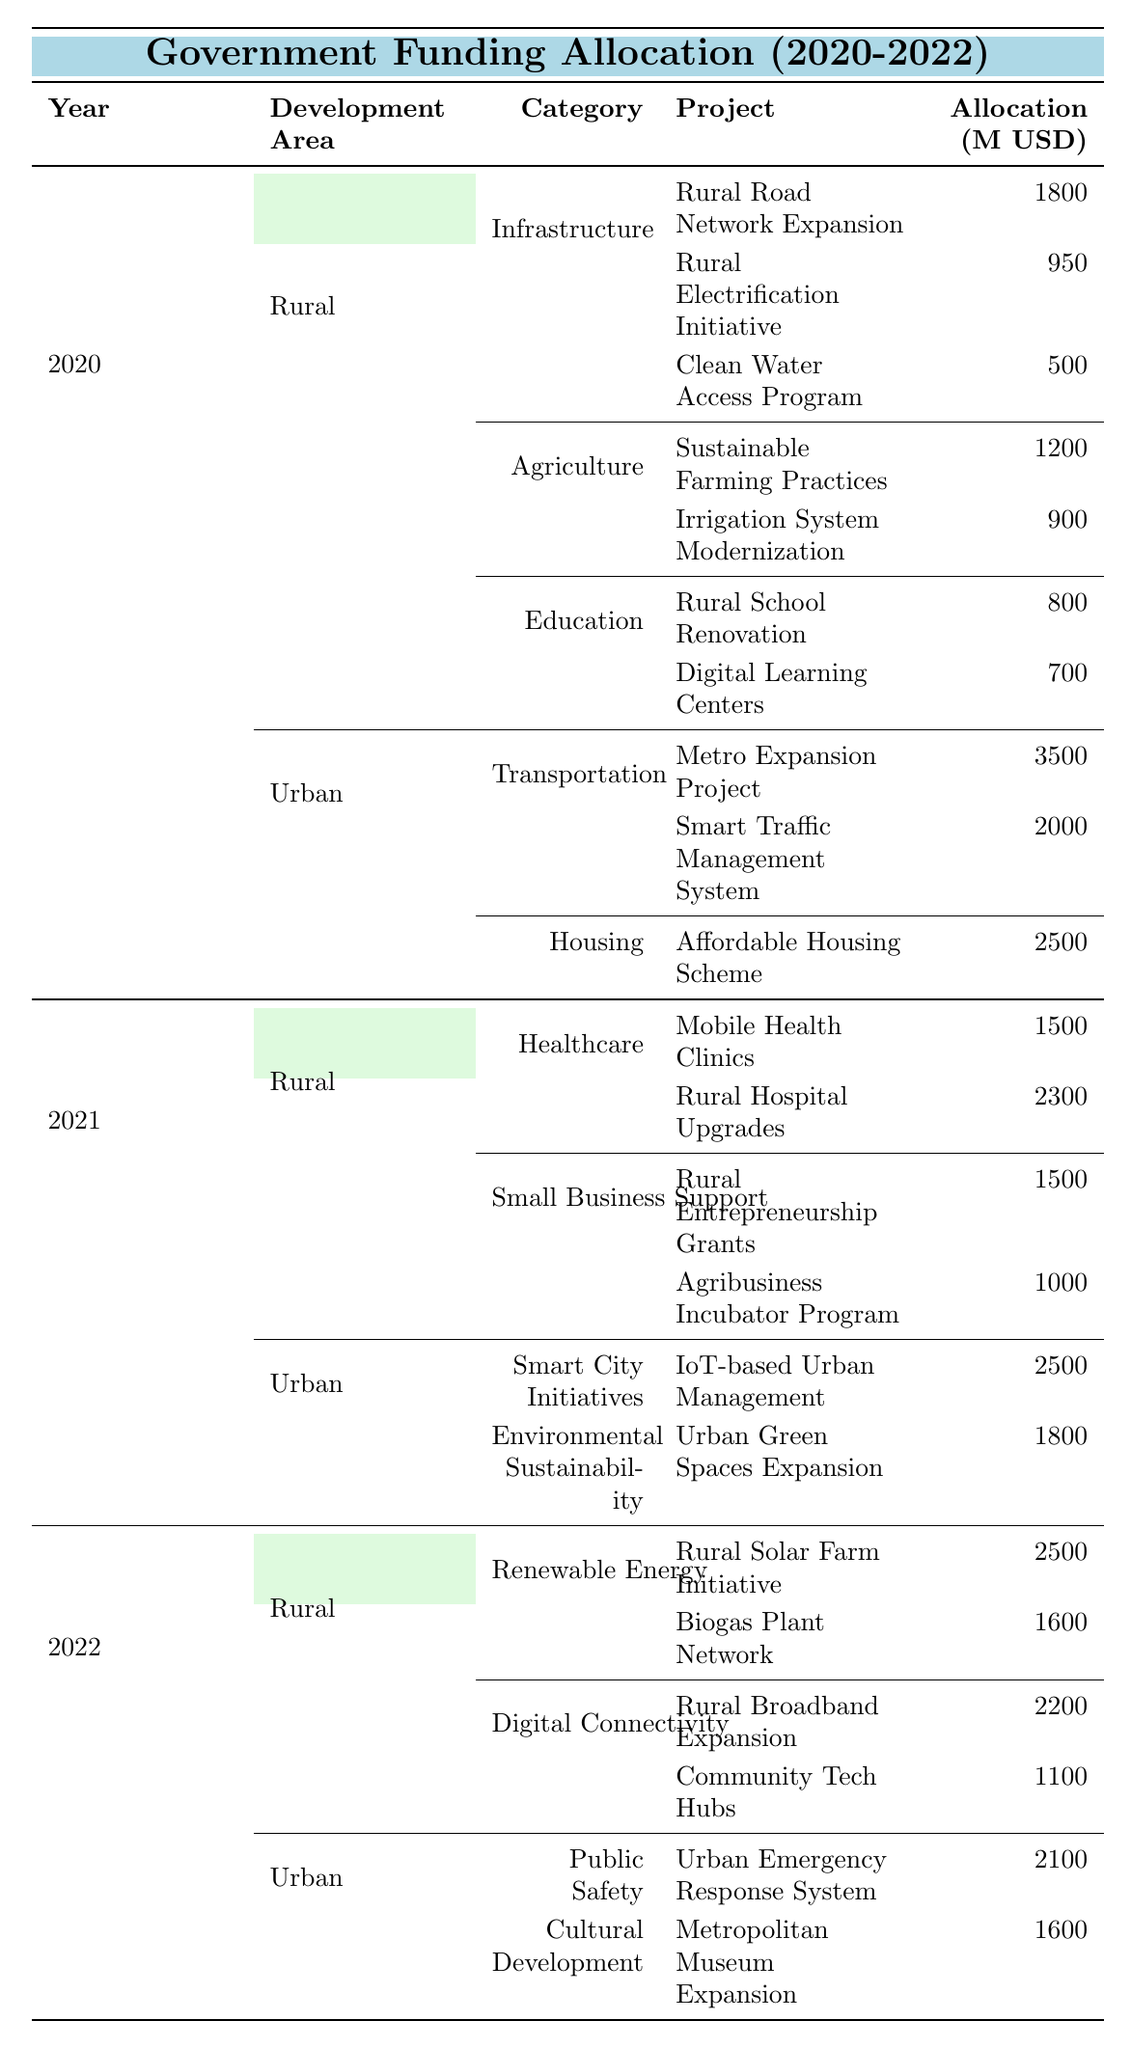What was the total allocation for rural development in 2020? In 2020, the rural development allocation consists of Infrastructure (3250 million USD), Agriculture (2100 million USD), and Education (1500 million USD). Adding these amounts gives: 3250 + 2100 + 1500 = 6850 million USD.
Answer: 6850 million USD Which urban project received the highest funding in 2021? In 2021, the highest funded urban project is the "IoT-based Urban Management" with an allocation of 2500 million USD under the Smart City Initiatives category.
Answer: 2500 million USD Did any rural projects receive more than 2000 million USD in allocations in 2022? In 2022, "Rural Solar Farm Initiative" received 2500 million USD and "Rural Hospital Upgrades" in 2021 received 2300 million USD. Both exceed 2000 million USD.
Answer: Yes What was the difference in funding allocation for urban vs. rural development in 2021? In 2021, rural development received a total of 6300 million USD (3800 million for Healthcare + 2500 million for Small Business Support) while urban development received 7310 million USD (4200 million for Smart City Initiatives + 3100 million for Environmental Sustainability). The difference is 7310 - 6300 = 1010 million USD.
Answer: 1010 million USD What percentage of the total funding in 2020 was allocated to urban development? In 2020, rural development received 6850 million USD while urban development received 9300 million USD (5500 million for Transportation + 3800 million for Housing). The total funding for 2020 is 6850 + 9300 = 16150 million USD. The percentage for urban development is (9300 / 16150) * 100 = 57.5%.
Answer: 57.5% How much funding was allocated to rural healthcare in 2021 compared to urban development? In 2021, rural healthcare received 3800 million USD (Mobile Health Clinics + Rural Hospital Upgrades) while urban development total is 7310 million USD. The rural allocation is less than urban development by 7310 - 3800 = 3510 million USD.
Answer: 3510 million USD less Which rural category saw the highest funding allocation over the three years? The highest rural funding category is "Infrastructure" with allocations of 3250 million USD in 2020, not surpassed in the following years.
Answer: Infrastructure What was the total funding allocated to education projects in rural development during 2020? In 2020, the allocated funding for education projects was 1500 million USD, specifically for Rural School Renovation (800 million USD) and Digital Learning Centers (700 million USD).
Answer: 1500 million USD In which year did rural development receive the highest total funding? To determine this, we add the total funding for rural development across years: 6850 million USD in 2020, 6300 million USD in 2021, and 7400 million USD in 2022. The highest total is in 2022.
Answer: 2022 Did urban development project allocations in 2020 exceed those in 2021? In 2020, urban development received 9300 million USD, and in 2021, it received 7310 million USD. Therefore, the 2020 allocation does exceed 2021's.
Answer: Yes What projects made up the agricultural funding in rural development in 2020? The agricultural funding in 2020 is composed of "Sustainable Farming Practices" (1200 million USD) and "Irrigation System Modernization" (900 million USD), totaling 2100 million USD.
Answer: Sustainable Farming Practices and Irrigation System Modernization 